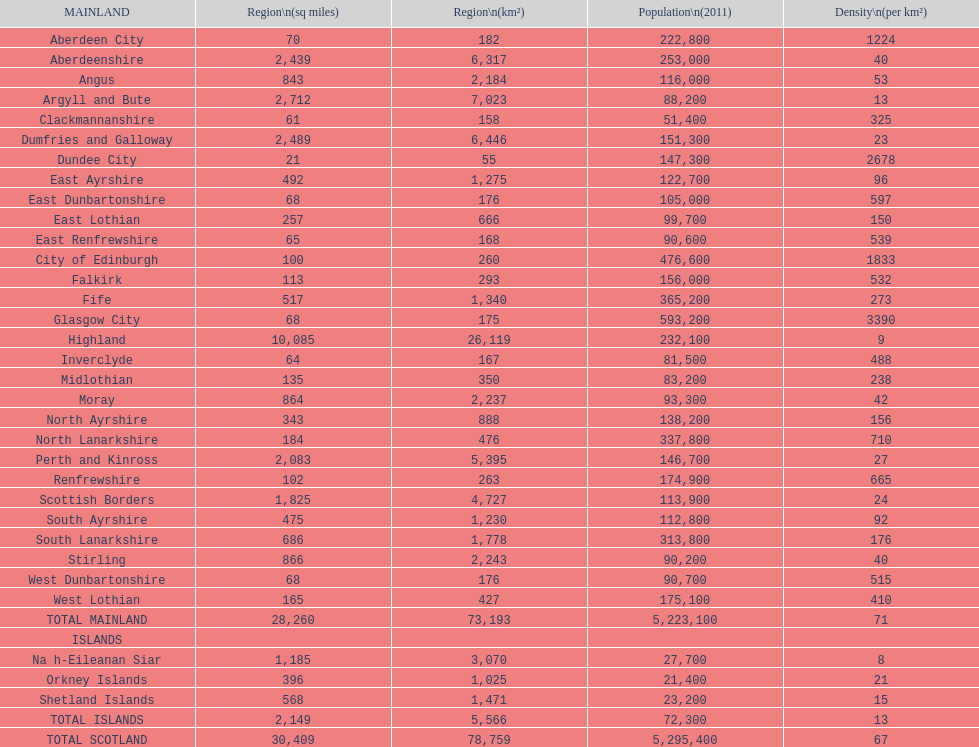If you were to arrange the locations from the smallest to largest area, which one would be first on the list? Dundee City. 